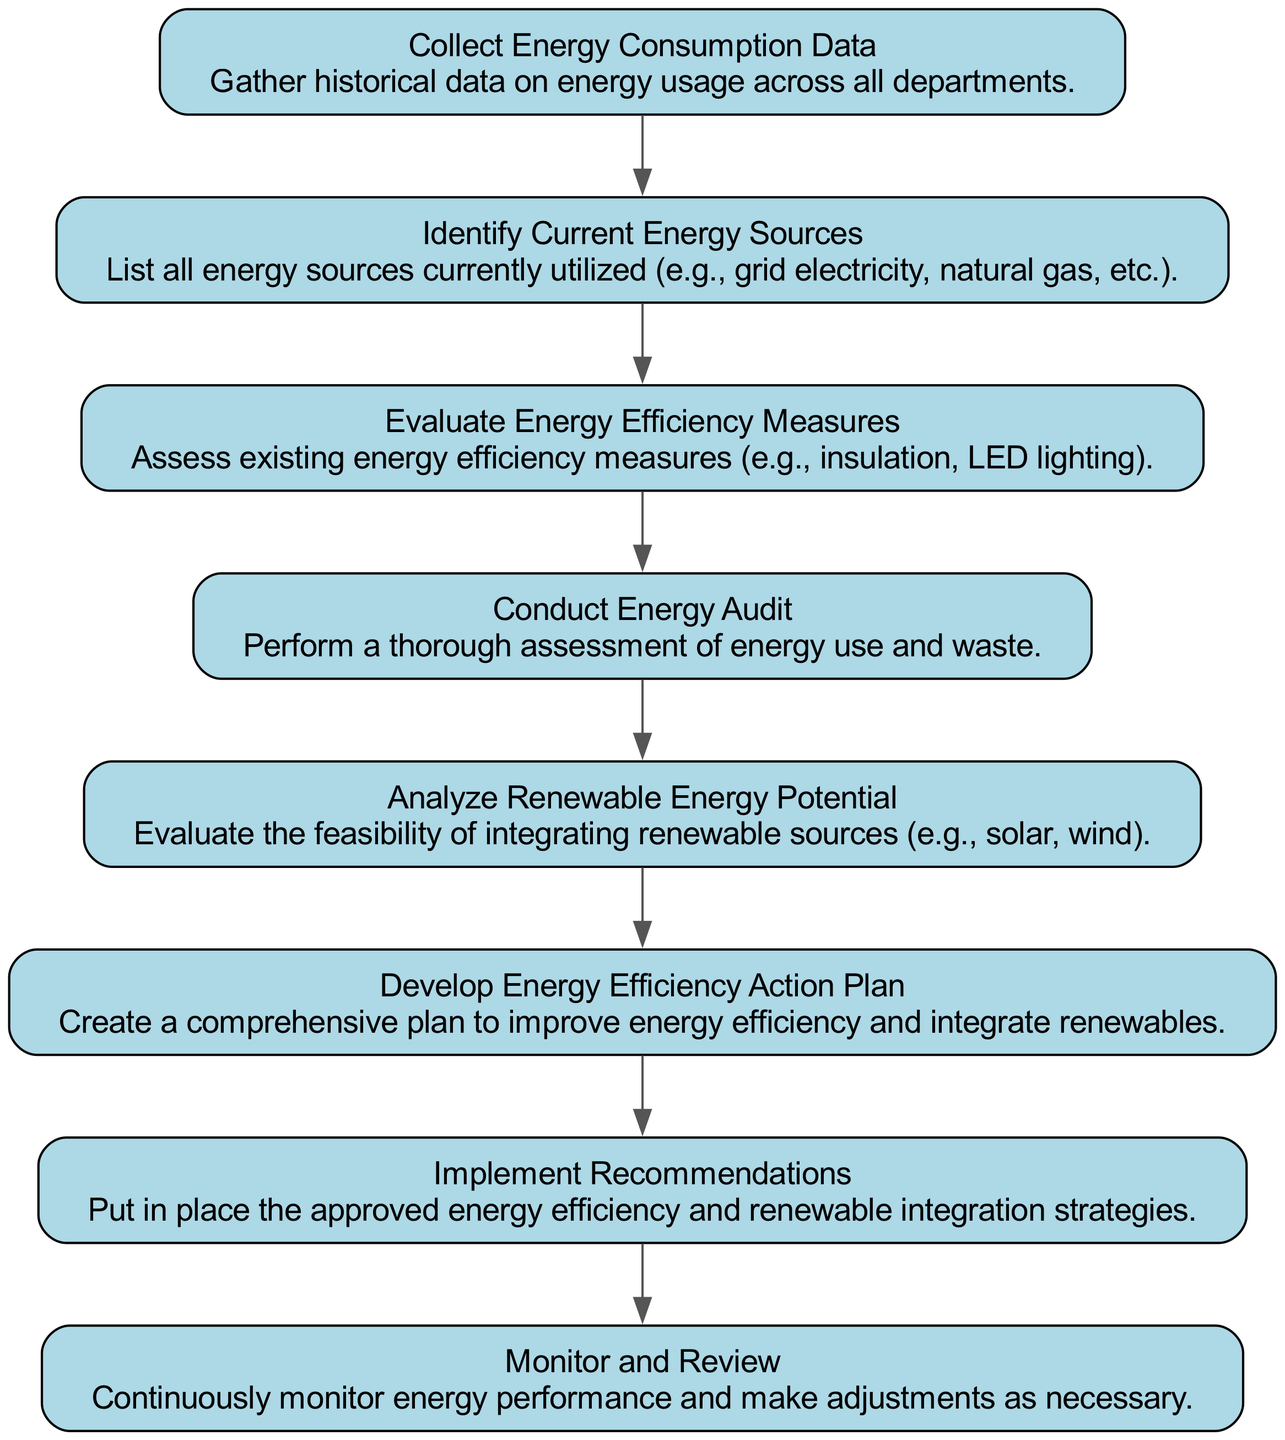What is the first step in the flow chart? The flow chart begins with the node "Collect Energy Consumption Data," which indicates that the first action is to gather historical data on energy usage.
Answer: Collect Energy Consumption Data How many nodes are present in the diagram? The diagram has a total of eight nodes, each representing a distinct step in the energy assessment process.
Answer: Eight Which step involves evaluating the feasibility of integrating renewable sources? The step that focuses on evaluating renewable sources is "Analyze Renewable Energy Potential," which specifically assesses the potential for solar, wind, or other renewables.
Answer: Analyze Renewable Energy Potential What is the relationship between "Conduct Energy Audit" and "Implement Recommendations"? "Conduct Energy Audit" leads to "Implement Recommendations" as it is necessary to perform the audit first before recommendations can be made and implemented.
Answer: Sequential relationship What is the last step in the flow chart? The final step illustrated in the flow chart is "Monitor and Review," which signifies the continuous oversight of energy performance post-implementation of strategies.
Answer: Monitor and Review What task directly follows the evaluation of energy efficiency measures? Following the "Evaluate Energy Efficiency Measures," the next task in the flow is "Conduct Energy Audit," indicating a progression in the assessment process.
Answer: Conduct Energy Audit How does the "Develop Energy Efficiency Action Plan" relate to the previous steps? The “Develop Energy Efficiency Action Plan” step is preceded by both "Conduct Energy Audit" and "Analyze Renewable Energy Potential," combining findings from both to create a robust action plan.
Answer: It combines findings from the previous two steps What is the primary purpose of the flow chart? The primary purpose of this flow chart is to strategically outline the assessment process for energy sources and efficiency measures, ultimately leading to improved energy use practices.
Answer: Assessment of Current Energy Sources and Efficiency Measures 